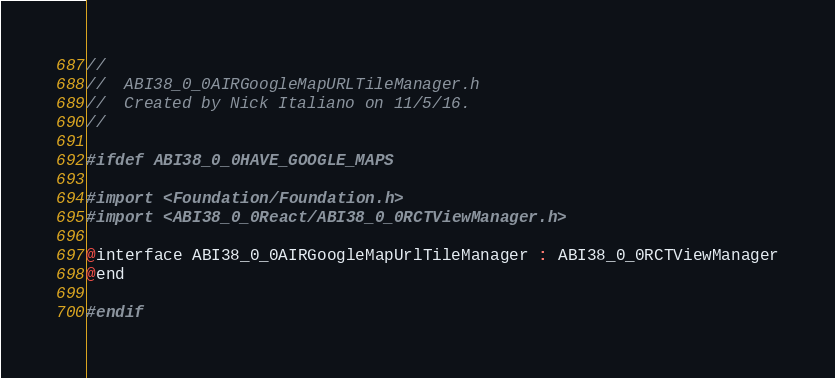<code> <loc_0><loc_0><loc_500><loc_500><_C_>//
//  ABI38_0_0AIRGoogleMapURLTileManager.h
//  Created by Nick Italiano on 11/5/16.
//

#ifdef ABI38_0_0HAVE_GOOGLE_MAPS

#import <Foundation/Foundation.h>
#import <ABI38_0_0React/ABI38_0_0RCTViewManager.h>

@interface ABI38_0_0AIRGoogleMapUrlTileManager : ABI38_0_0RCTViewManager
@end

#endif
</code> 